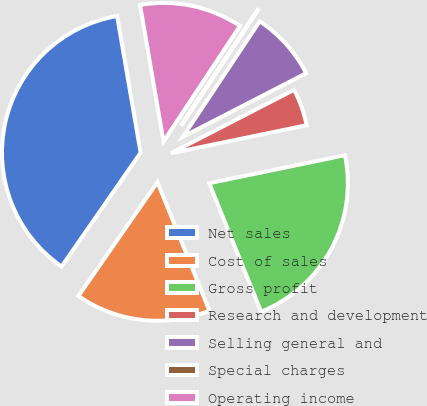<chart> <loc_0><loc_0><loc_500><loc_500><pie_chart><fcel>Net sales<fcel>Cost of sales<fcel>Gross profit<fcel>Research and development<fcel>Selling general and<fcel>Special charges<fcel>Operating income<nl><fcel>37.64%<fcel>15.77%<fcel>22.13%<fcel>4.33%<fcel>8.09%<fcel>0.04%<fcel>12.01%<nl></chart> 